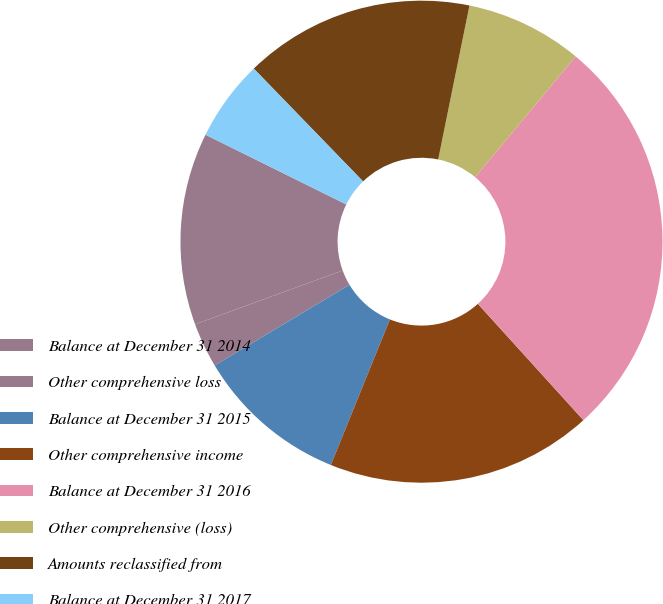Convert chart. <chart><loc_0><loc_0><loc_500><loc_500><pie_chart><fcel>Balance at December 31 2014<fcel>Other comprehensive loss<fcel>Balance at December 31 2015<fcel>Other comprehensive income<fcel>Balance at December 31 2016<fcel>Other comprehensive (loss)<fcel>Amounts reclassified from<fcel>Balance at December 31 2017<nl><fcel>12.89%<fcel>3.01%<fcel>10.28%<fcel>17.86%<fcel>27.23%<fcel>7.85%<fcel>15.44%<fcel>5.43%<nl></chart> 